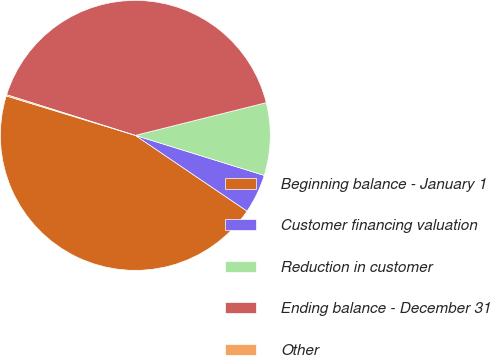Convert chart to OTSL. <chart><loc_0><loc_0><loc_500><loc_500><pie_chart><fcel>Beginning balance - January 1<fcel>Customer financing valuation<fcel>Reduction in customer<fcel>Ending balance - December 31<fcel>Other<nl><fcel>45.24%<fcel>4.69%<fcel>8.69%<fcel>41.23%<fcel>0.15%<nl></chart> 